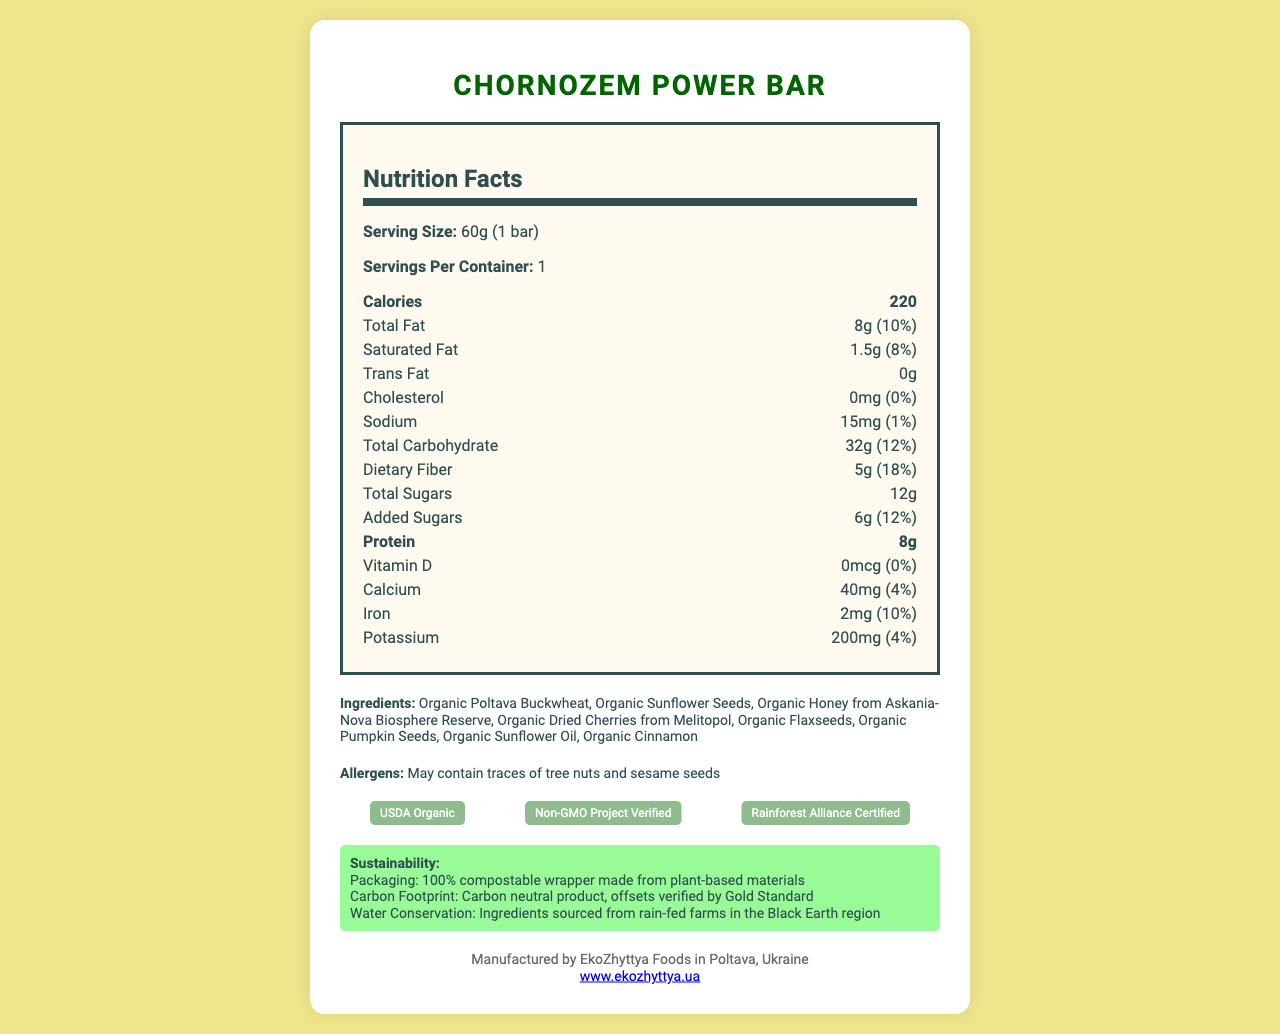what is the serving size of the Chornozem Power Bar? The serving size is specified as 60g (1 bar) in the nutrition label section.
Answer: 60g (1 bar) how many grams of protein does this energy bar contain? The amount of protein is listed as 8g in the nutrition label section.
Answer: 8g what is the amount of dietary fiber in one serving? The nutritional information specifies the dietary fiber as 5g per serving.
Answer: 5g which ingredient from the Black Earth region is used for sweetening the bar? The ingredients section lists "Organic Honey from Askania-Nova Biosphere Reserve" as one of the ingredients.
Answer: Organic Honey from Askania-Nova Biosphere Reserve are there any tree nuts in the Chornozem Power Bar? The allergens section mentions that the bar may contain traces of tree nuts.
Answer: May contain traces of tree nuts how many calories are in one Chornozem Power Bar? The nutrition label indicates that one bar contains 220 calories.
Answer: 220 which of the following is true about the Chornozem Power Bar? A. It contains artificial sweeteners B. It has a high cholesterol content C. It is carbon neutral D. It is non-organic The sustainability section states that the product is carbon neutral, and the certification section mentions "USDA Organic".
Answer: C what is the percentage of daily value for iron provided by the Chornozem Power Bar? A. 2% B. 4% C. 10% D. 18% The nutrition label indicates that the bar provides 10% of the daily value for iron.
Answer: C does the bar have any added sugars? The nutrition label shows that there are 6g of added sugars in the bar, which accounts for 12% of the daily value.
Answer: Yes summarize the overall information presented in the document. The document provides detailed nutritional information, ingredients, allergen warnings, certifications, sustainability information, and manufacturer details, emphasizing the bar's eco-friendly and health-conscious features.
Answer: The Chornozem Power Bar is an eco-friendly energy bar made with ingredients from Ukraine's historical Black Earth region. It contains 220 calories per serving and has various nutrients like protein (8g), fiber (5g), and iron (10% DV). The ingredients are all organic, and the bar is certified USDA Organic, Non-GMO Project Verified, and Rainforest Alliance Certified. It comes in a 100% compostable wrapper. The manufacturer, EkoZhyttya Foods, is based in Poltava, Ukraine. what is the amount of total carbohydrate in the Chornozem Power Bar? The nutrition label specifies that the bar contains 32g of total carbohydrate.
Answer: 32g who manufactures the Chornozem Power Bar? The manufacturer info section states that the bar is manufactured by EkoZhyttya Foods located in Poltava, Ukraine.
Answer: EkoZhyttya Foods what is the website of the manufacturer? The manufacturer info section provides the website as www.ekozhyttya.ua.
Answer: www.ekozhyttya.ua what certifications does the Chornozem Power Bar have? A. USDA Organic B. Non-GMO Project Verified C. Rainforest Alliance Certified D. All of the above The certifications section lists USDA Organic, Non-GMO Project Verified, and Rainforest Alliance Certified.
Answer: D what is the source of the organic dried cherries? The ingredients section notes that the organic dried cherries come from Melitopol.
Answer: Melitopol is the packaging of the Chornozem Power Bar compostable? The sustainability section mentions that the packaging is made from 100% compostable plant-based materials.
Answer: Yes what is the carbon footprint status of the Chornozem Power Bar? The sustainability section specifies that the product is carbon neutral, with offsets verified by Gold Standard.
Answer: Carbon neutral how much calcium does one Chornozem Power Bar contain? The nutrition label shows that one bar contains 40mg of calcium, which is 4% of the daily value.
Answer: 40mg where is the organic honey sourced from? The ingredients section specifies that the organic honey comes from Askania-Nova Biosphere Reserve.
Answer: Askania-Nova Biosphere Reserve what percentage of the daily value of saturated fat does the bar provide? According to the nutrition label, the bar provides 8% of the daily value for saturated fat.
Answer: 8% what is the name of the energy bar featured in the document? The title and product name mentioned at the beginning of the document is Chornozem Power Bar.
Answer: Chornozem Power Bar what is the total amount of sugars in the Chornozem Power Bar, including added sugars? The nutrition label notes that the bar has a total of 12g of sugars, which includes 6g of added sugars.
Answer: 12g what is the cholesterol content in the Chornozem Power Bar? The nutrition label specifies that the bar contains 0mg of cholesterol.
Answer: 0mg does the bar contain any vitamin D? The nutrition label indicates that the bar contains 0mcg of vitamin D, which is 0% of the daily value.
Answer: No what is the primary ingredient of the Chornozem Power Bar? The ingredients section lists Organic Poltava Buckwheat as the first ingredient, indicating it is the primary ingredient.
Answer: Organic Poltava Buckwheat is the water used for the ingredients sourced from irrigation? The sustainability section states that ingredients are sourced from rain-fed farms in the Black Earth region.
Answer: No 